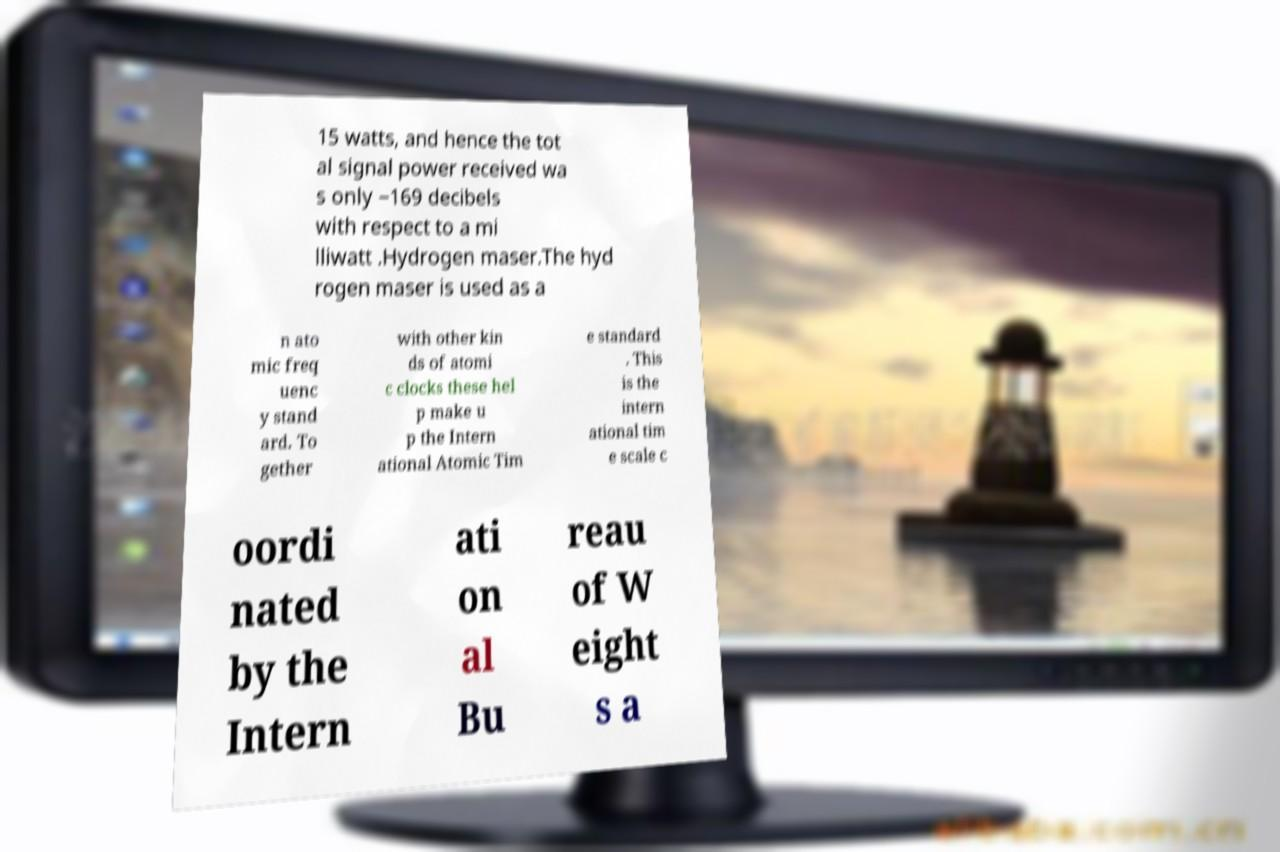Could you assist in decoding the text presented in this image and type it out clearly? 15 watts, and hence the tot al signal power received wa s only −169 decibels with respect to a mi lliwatt .Hydrogen maser.The hyd rogen maser is used as a n ato mic freq uenc y stand ard. To gether with other kin ds of atomi c clocks these hel p make u p the Intern ational Atomic Tim e standard . This is the intern ational tim e scale c oordi nated by the Intern ati on al Bu reau of W eight s a 